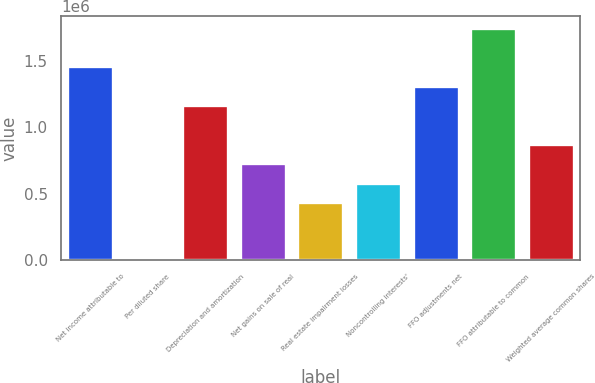<chart> <loc_0><loc_0><loc_500><loc_500><bar_chart><fcel>Net income attributable to<fcel>Per diluted share<fcel>Depreciation and amortization<fcel>Net gains on sale of real<fcel>Real estate impairment losses<fcel>Noncontrolling interests'<fcel>FFO adjustments net<fcel>FFO attributable to common<fcel>Weighted average common shares<nl><fcel>1.45758e+06<fcel>4.34<fcel>1.16607e+06<fcel>728794<fcel>437278<fcel>583036<fcel>1.31183e+06<fcel>1.7491e+06<fcel>874552<nl></chart> 